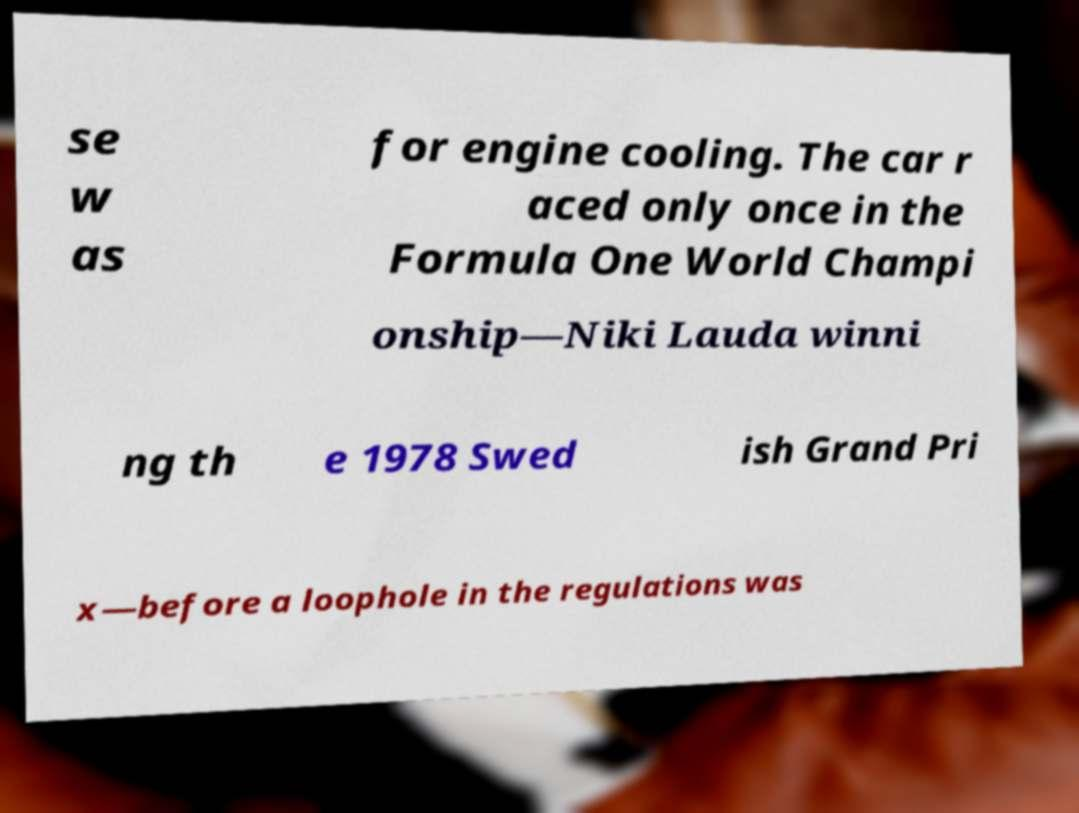I need the written content from this picture converted into text. Can you do that? se w as for engine cooling. The car r aced only once in the Formula One World Champi onship—Niki Lauda winni ng th e 1978 Swed ish Grand Pri x—before a loophole in the regulations was 